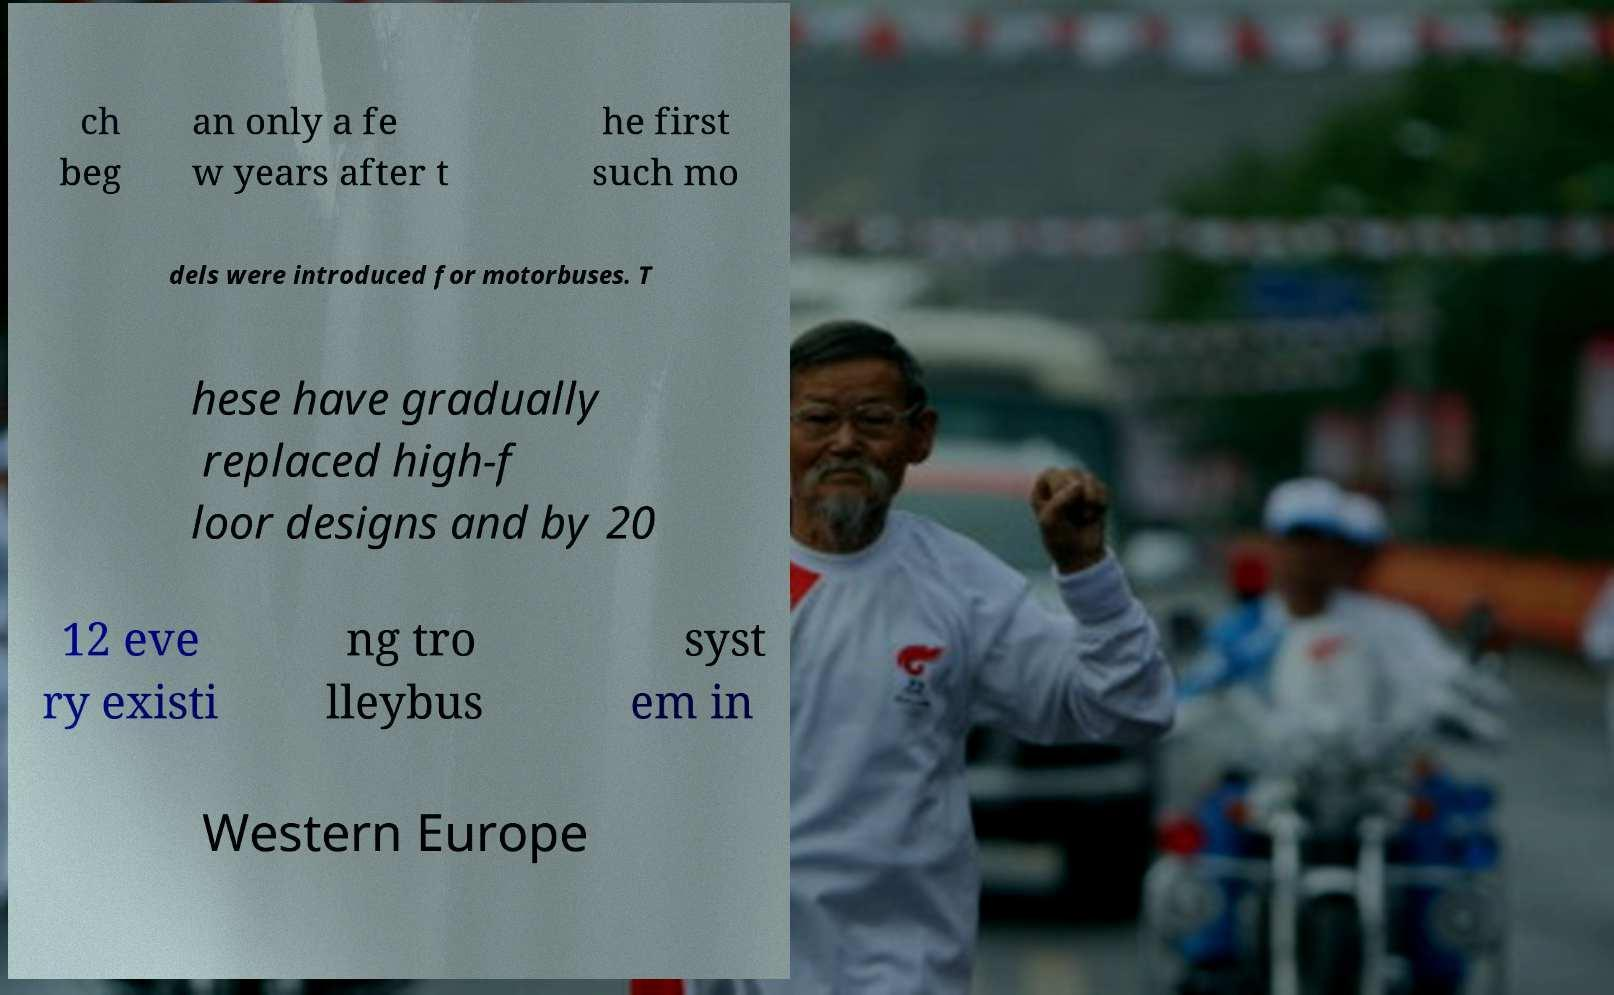What messages or text are displayed in this image? I need them in a readable, typed format. ch beg an only a fe w years after t he first such mo dels were introduced for motorbuses. T hese have gradually replaced high-f loor designs and by 20 12 eve ry existi ng tro lleybus syst em in Western Europe 